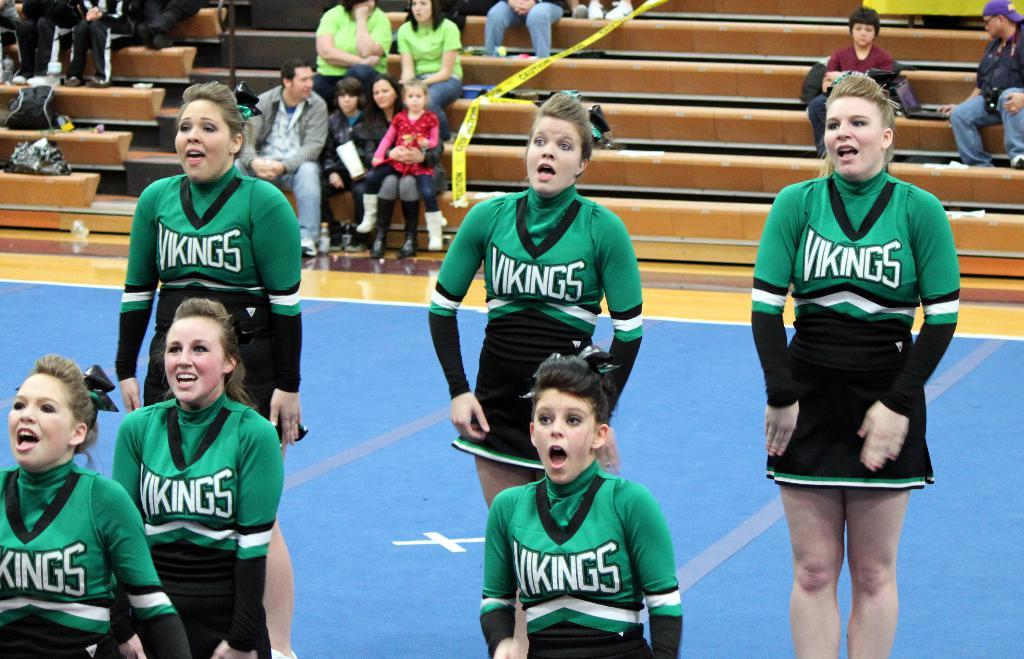Provide a one-sentence caption for the provided image. A high school cheer squad performs on court at a Vikings basketball game. 